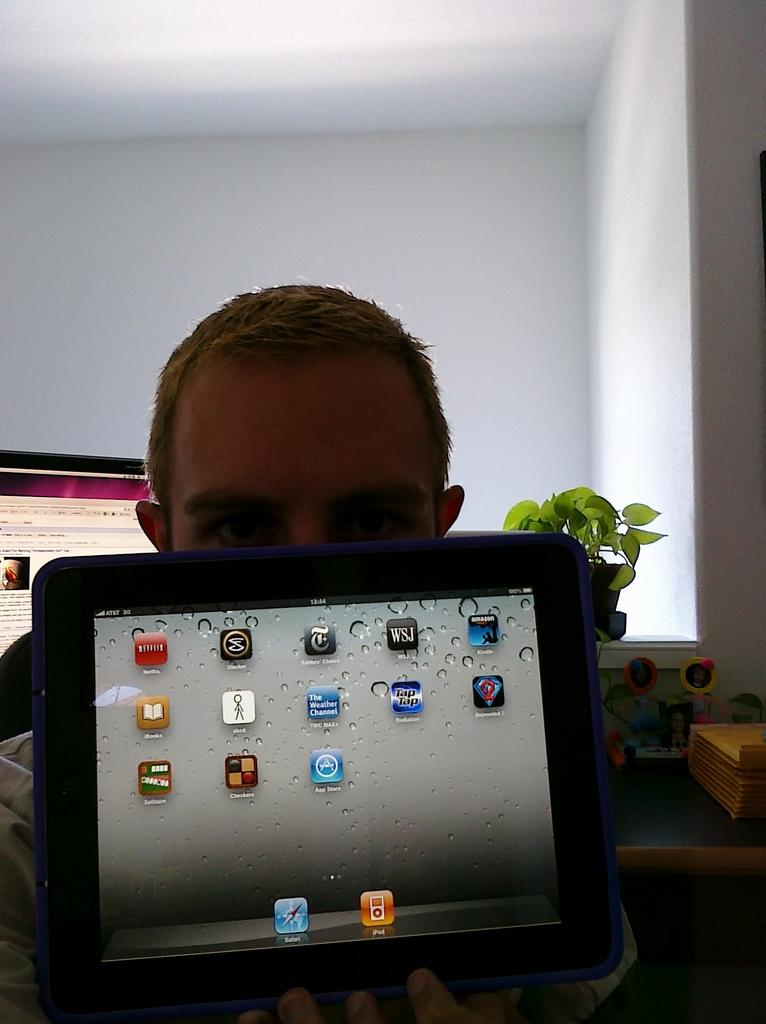What is the main subject of the image? There is a person standing in the center of the image. What is the person holding in the image? The person is holding a tablet. What can be seen in the background of the image? There is a houseplant, a monitor, objects placed on a table, and a wall visible in the background of the image. What type of fuel is being used by the industry depicted in the image? There is no industry or fuel present in the image; it features a person holding a tablet and various background elements. 